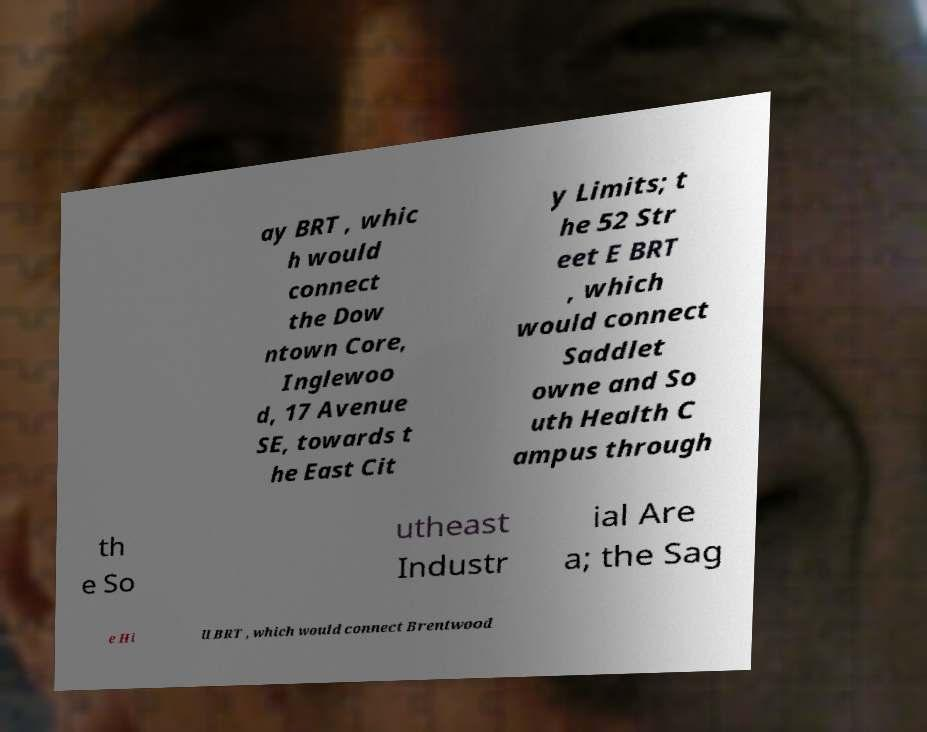Can you accurately transcribe the text from the provided image for me? ay BRT , whic h would connect the Dow ntown Core, Inglewoo d, 17 Avenue SE, towards t he East Cit y Limits; t he 52 Str eet E BRT , which would connect Saddlet owne and So uth Health C ampus through th e So utheast Industr ial Are a; the Sag e Hi ll BRT , which would connect Brentwood 